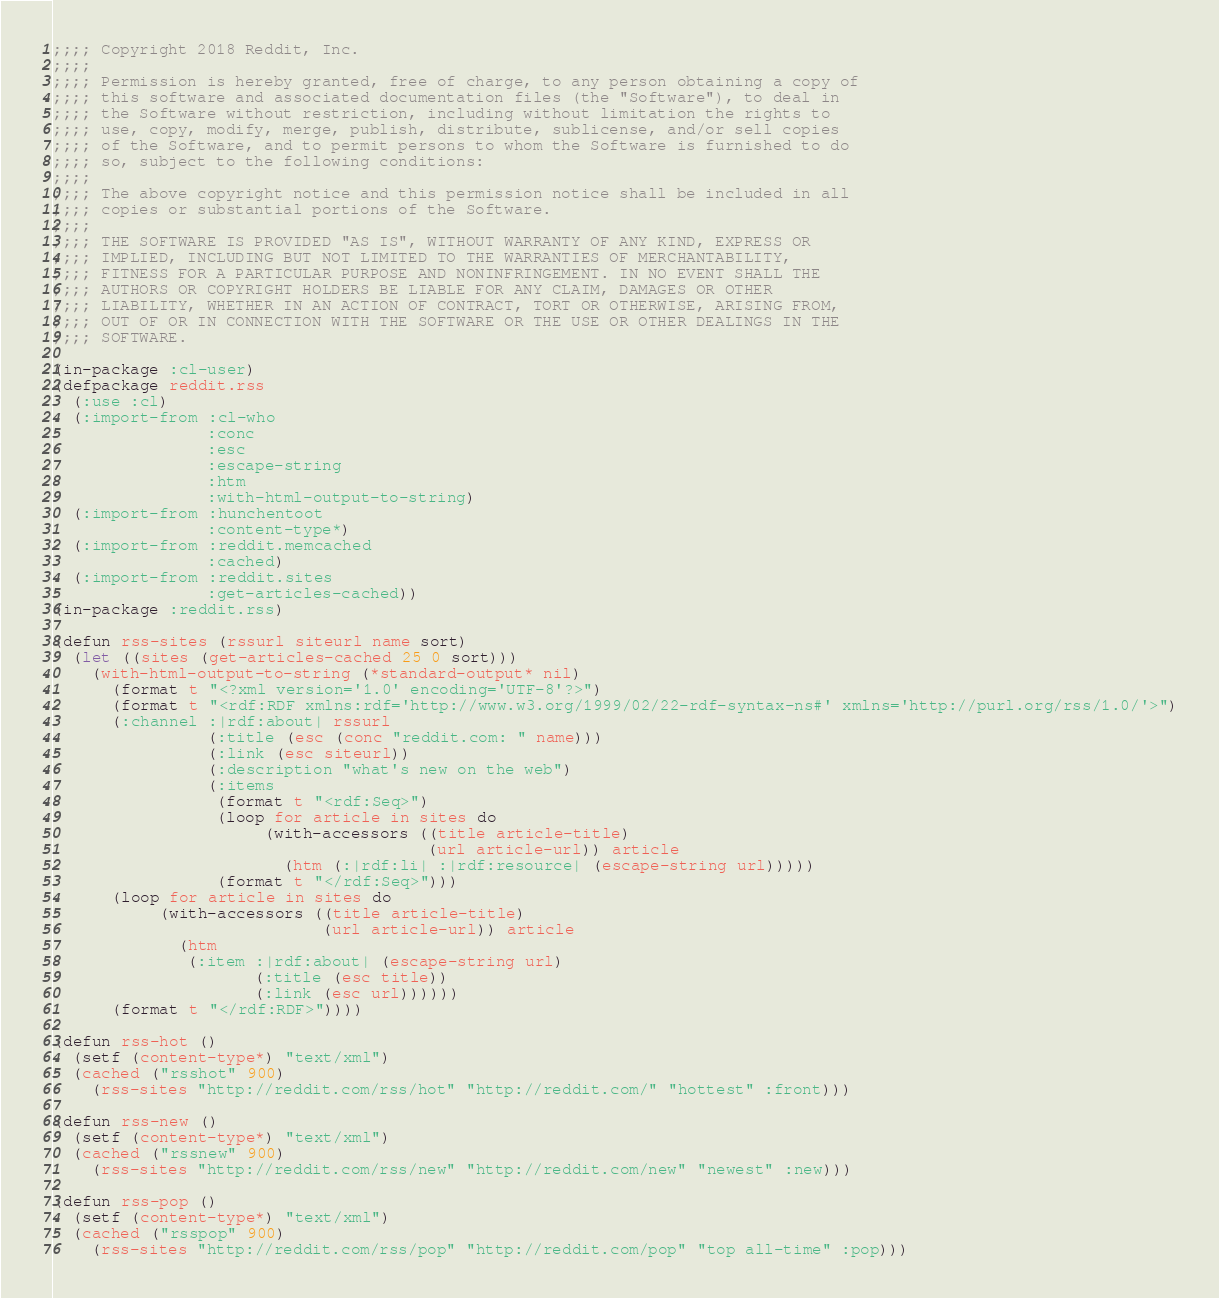<code> <loc_0><loc_0><loc_500><loc_500><_Lisp_>;;;; Copyright 2018 Reddit, Inc.
;;;; 
;;;; Permission is hereby granted, free of charge, to any person obtaining a copy of
;;;; this software and associated documentation files (the "Software"), to deal in
;;;; the Software without restriction, including without limitation the rights to
;;;; use, copy, modify, merge, publish, distribute, sublicense, and/or sell copies
;;;; of the Software, and to permit persons to whom the Software is furnished to do
;;;; so, subject to the following conditions:
;;;; 
;;;; The above copyright notice and this permission notice shall be included in all
;;;; copies or substantial portions of the Software.
;;;; 
;;;; THE SOFTWARE IS PROVIDED "AS IS", WITHOUT WARRANTY OF ANY KIND, EXPRESS OR
;;;; IMPLIED, INCLUDING BUT NOT LIMITED TO THE WARRANTIES OF MERCHANTABILITY,
;;;; FITNESS FOR A PARTICULAR PURPOSE AND NONINFRINGEMENT. IN NO EVENT SHALL THE
;;;; AUTHORS OR COPYRIGHT HOLDERS BE LIABLE FOR ANY CLAIM, DAMAGES OR OTHER
;;;; LIABILITY, WHETHER IN AN ACTION OF CONTRACT, TORT OR OTHERWISE, ARISING FROM,
;;;; OUT OF OR IN CONNECTION WITH THE SOFTWARE OR THE USE OR OTHER DEALINGS IN THE
;;;; SOFTWARE.

(in-package :cl-user)
(defpackage reddit.rss
  (:use :cl)
  (:import-from :cl-who
                :conc
                :esc
                :escape-string
                :htm
                :with-html-output-to-string)
  (:import-from :hunchentoot
                :content-type*)
  (:import-from :reddit.memcached
                :cached)
  (:import-from :reddit.sites
                :get-articles-cached))
(in-package :reddit.rss)

(defun rss-sites (rssurl siteurl name sort)
  (let ((sites (get-articles-cached 25 0 sort)))
    (with-html-output-to-string (*standard-output* nil)
      (format t "<?xml version='1.0' encoding='UTF-8'?>")
      (format t "<rdf:RDF xmlns:rdf='http://www.w3.org/1999/02/22-rdf-syntax-ns#' xmlns='http://purl.org/rss/1.0/'>")
      (:channel :|rdf:about| rssurl
                (:title (esc (conc "reddit.com: " name)))
                (:link (esc siteurl))
                (:description "what's new on the web")
                (:items
                 (format t "<rdf:Seq>")
                 (loop for article in sites do
                      (with-accessors ((title article-title)
                                       (url article-url)) article
                        (htm (:|rdf:li| :|rdf:resource| (escape-string url)))))
                 (format t "</rdf:Seq>")))
      (loop for article in sites do
           (with-accessors ((title article-title)
                            (url article-url)) article
             (htm
              (:item :|rdf:about| (escape-string url)
                     (:title (esc title))
                     (:link (esc url))))))
      (format t "</rdf:RDF>"))))
  
(defun rss-hot ()
  (setf (content-type*) "text/xml")
  (cached ("rsshot" 900)
    (rss-sites "http://reddit.com/rss/hot" "http://reddit.com/" "hottest" :front)))

(defun rss-new ()
  (setf (content-type*) "text/xml")
  (cached ("rssnew" 900)
    (rss-sites "http://reddit.com/rss/new" "http://reddit.com/new" "newest" :new)))

(defun rss-pop ()
  (setf (content-type*) "text/xml")
  (cached ("rsspop" 900)
    (rss-sites "http://reddit.com/rss/pop" "http://reddit.com/pop" "top all-time" :pop)))
</code> 